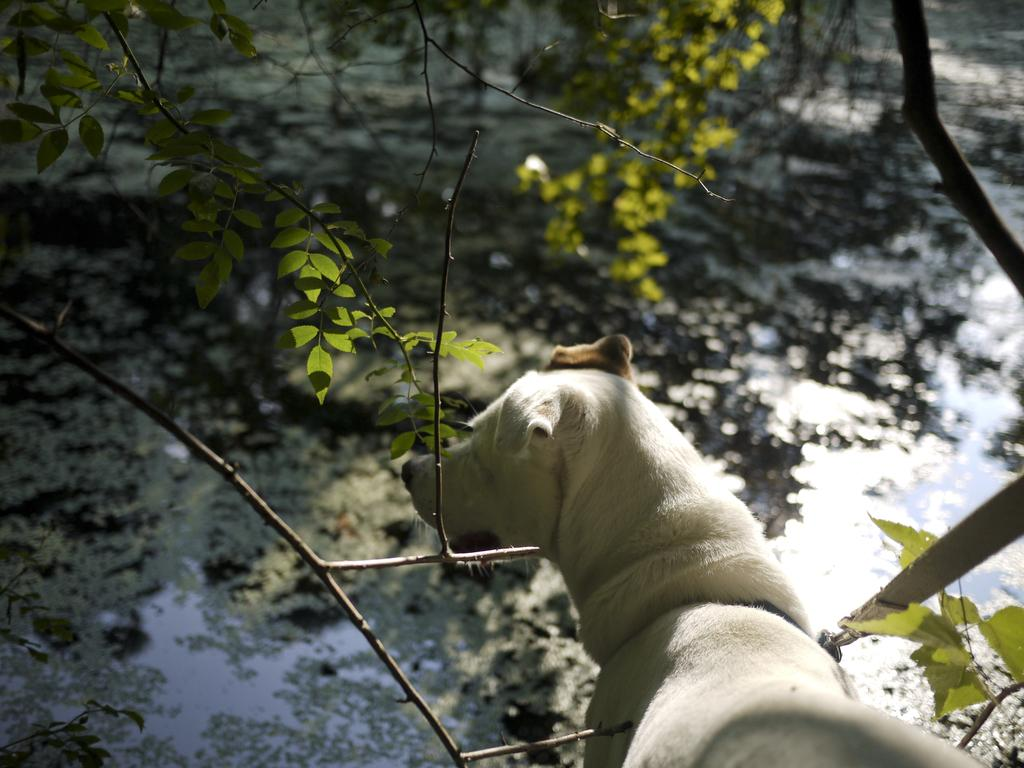What type of creature is present in the image? There is an animal in the image. What is the animal doing in the image? The animal is looking at something. What can be seen in front of the animal? There are trees and water in front of the animal. How does the animal feel shame in the image? There is no indication in the image that the animal is experiencing shame. 